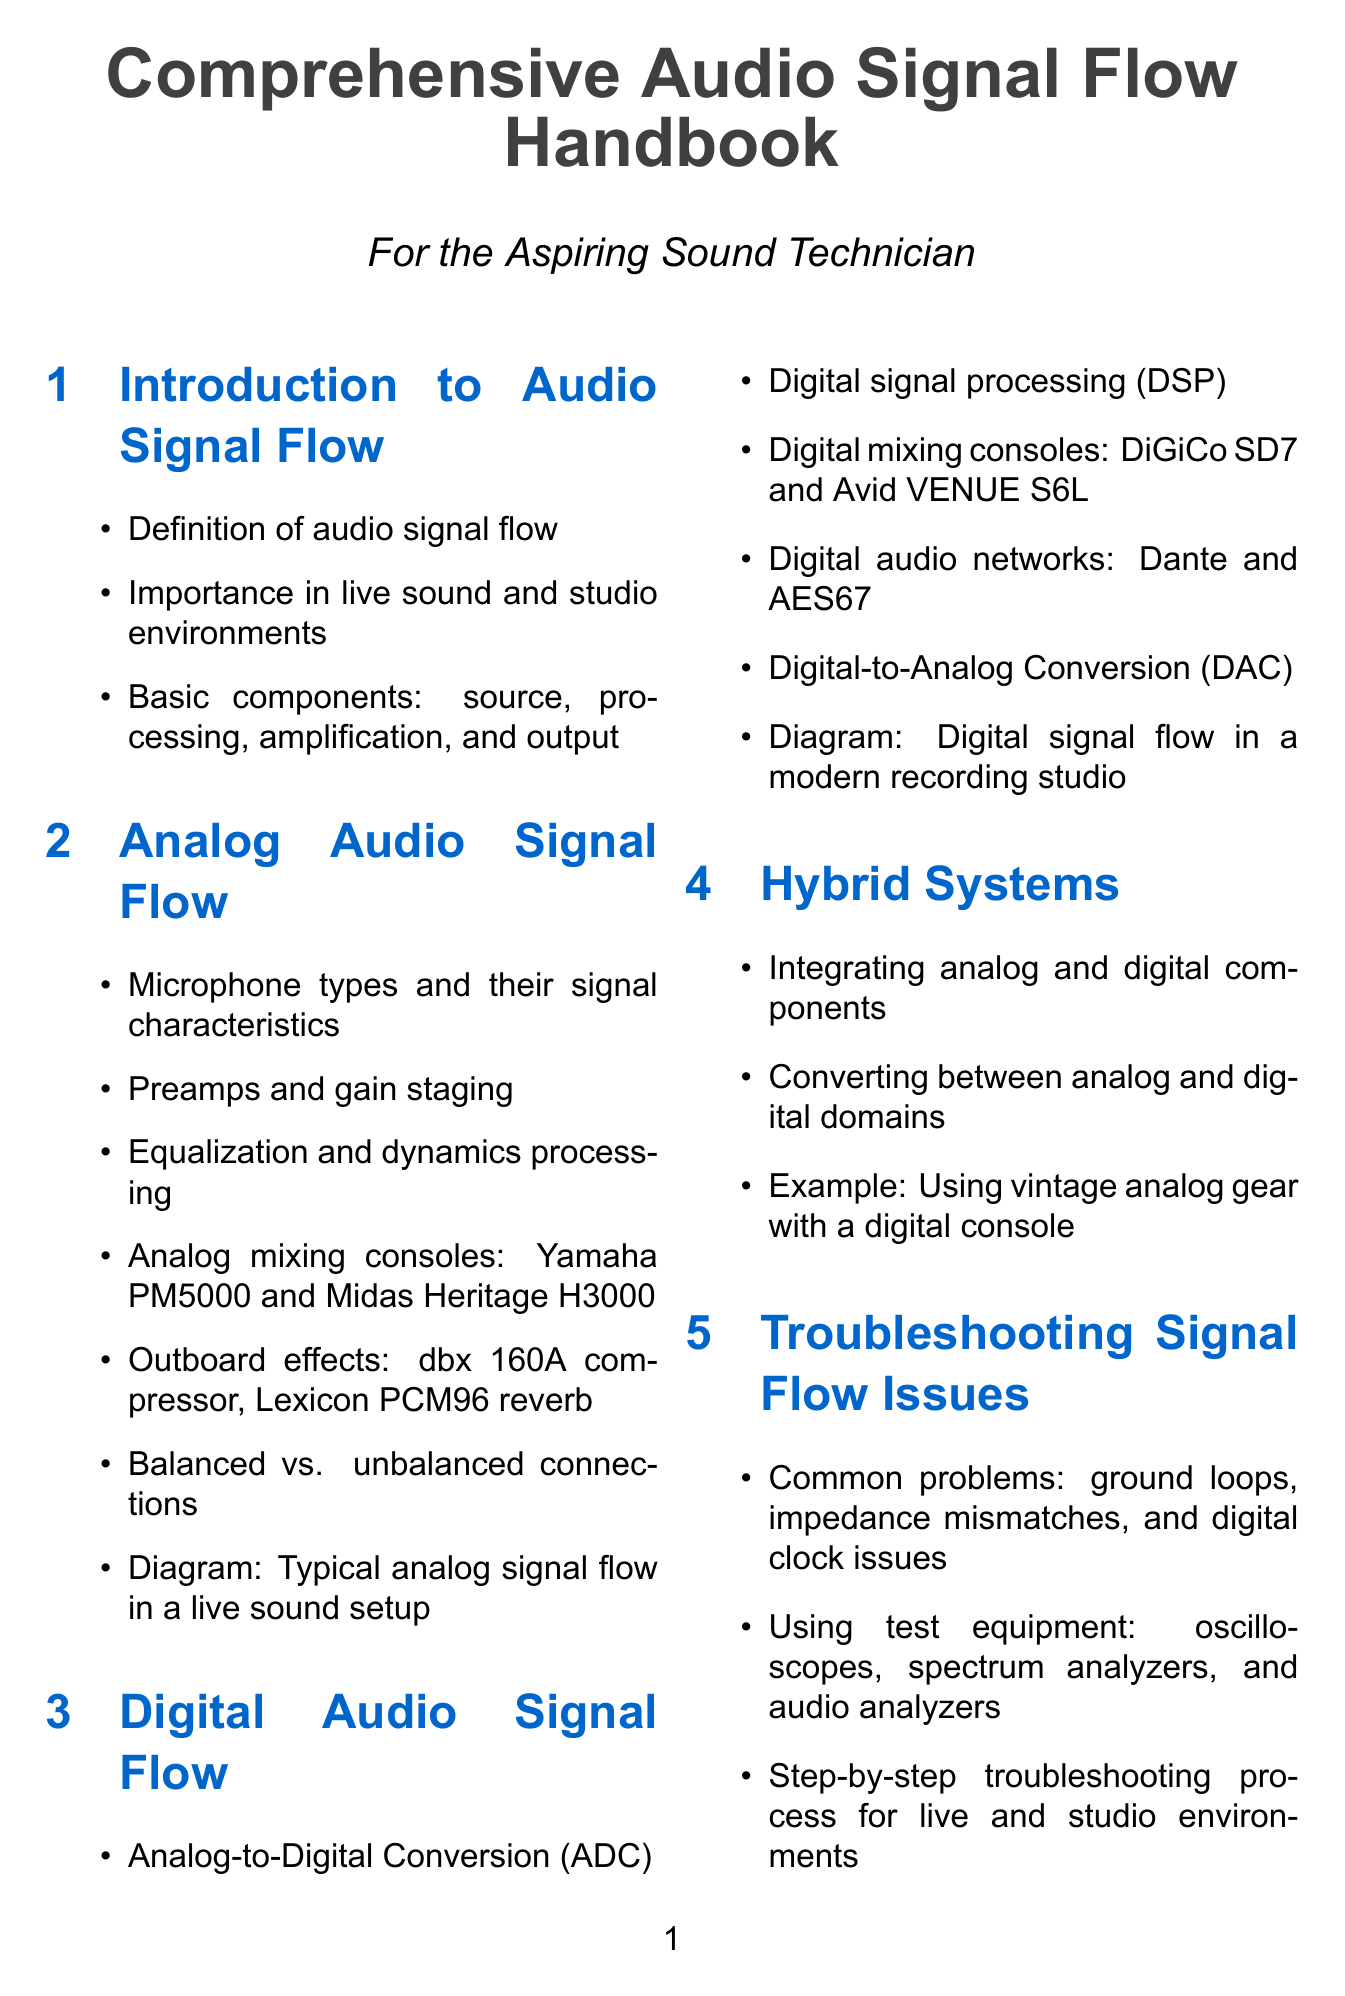What are the basic components of audio signal flow? The basic components of audio signal flow are mentioned in the introduction section of the document.
Answer: source, processing, amplification, and output Which digital mixing consoles are mentioned? The document lists specific digital mixing consoles under the digital audio signal flow section.
Answer: DiGiCo SD7 and Avid VENUE S6L What is the common problem related to digital clock issues? This problem is mentioned in the troubleshooting section, outlining common issues with signal flow.
Answer: digital clock issues What is one key example of an outboard effect? The document provides examples of outboard effects in the analog audio signal flow section.
Answer: dbx 160A compressor What type of systems are discussed in the advanced topics section? The advanced topics section covers a specific type of audio systems that enhance sound distribution.
Answer: Networked audio systems How many real-world case studies are presented? The real-world examples section includes different case studies related to audio signal flow.
Answer: Three What technology advancements are discussed in the future trends section? Specific advancements in audio technology are detailed in the future trends section of the document.
Answer: Audio-over-IP advancements What is the purpose of the appendices section? The appendices section provides supplementary information for those interested in further learning.
Answer: Supplementary information Which audio conversion processes are discussed in digital audio signal flow? The digital audio signal flow section mentions specific audio conversion processes critical for signal management.
Answer: Analog-to-Digital Conversion (ADC) and Digital-to-Analog Conversion (DAC) 